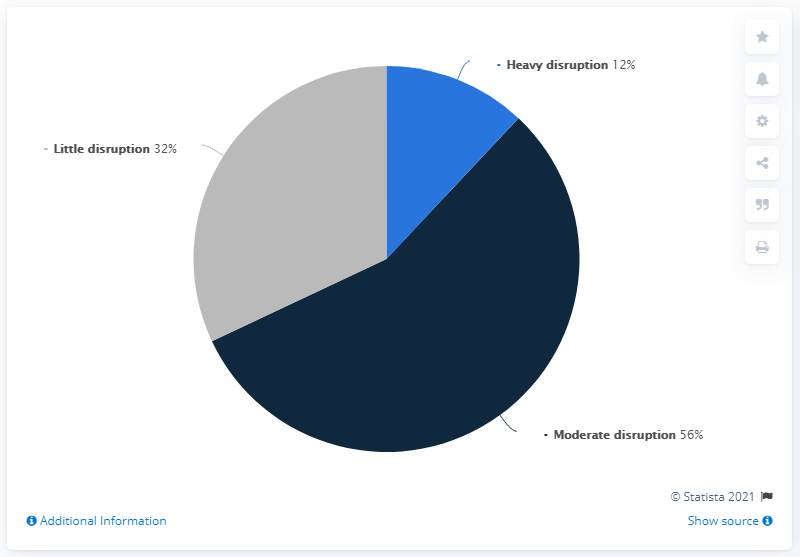Draw attention to some important aspects in this diagram. The moderate disruption supplier is currently estimated to be 56%. The percentage of moderate disruption is greater than that of heavy disruption among suppliers. 